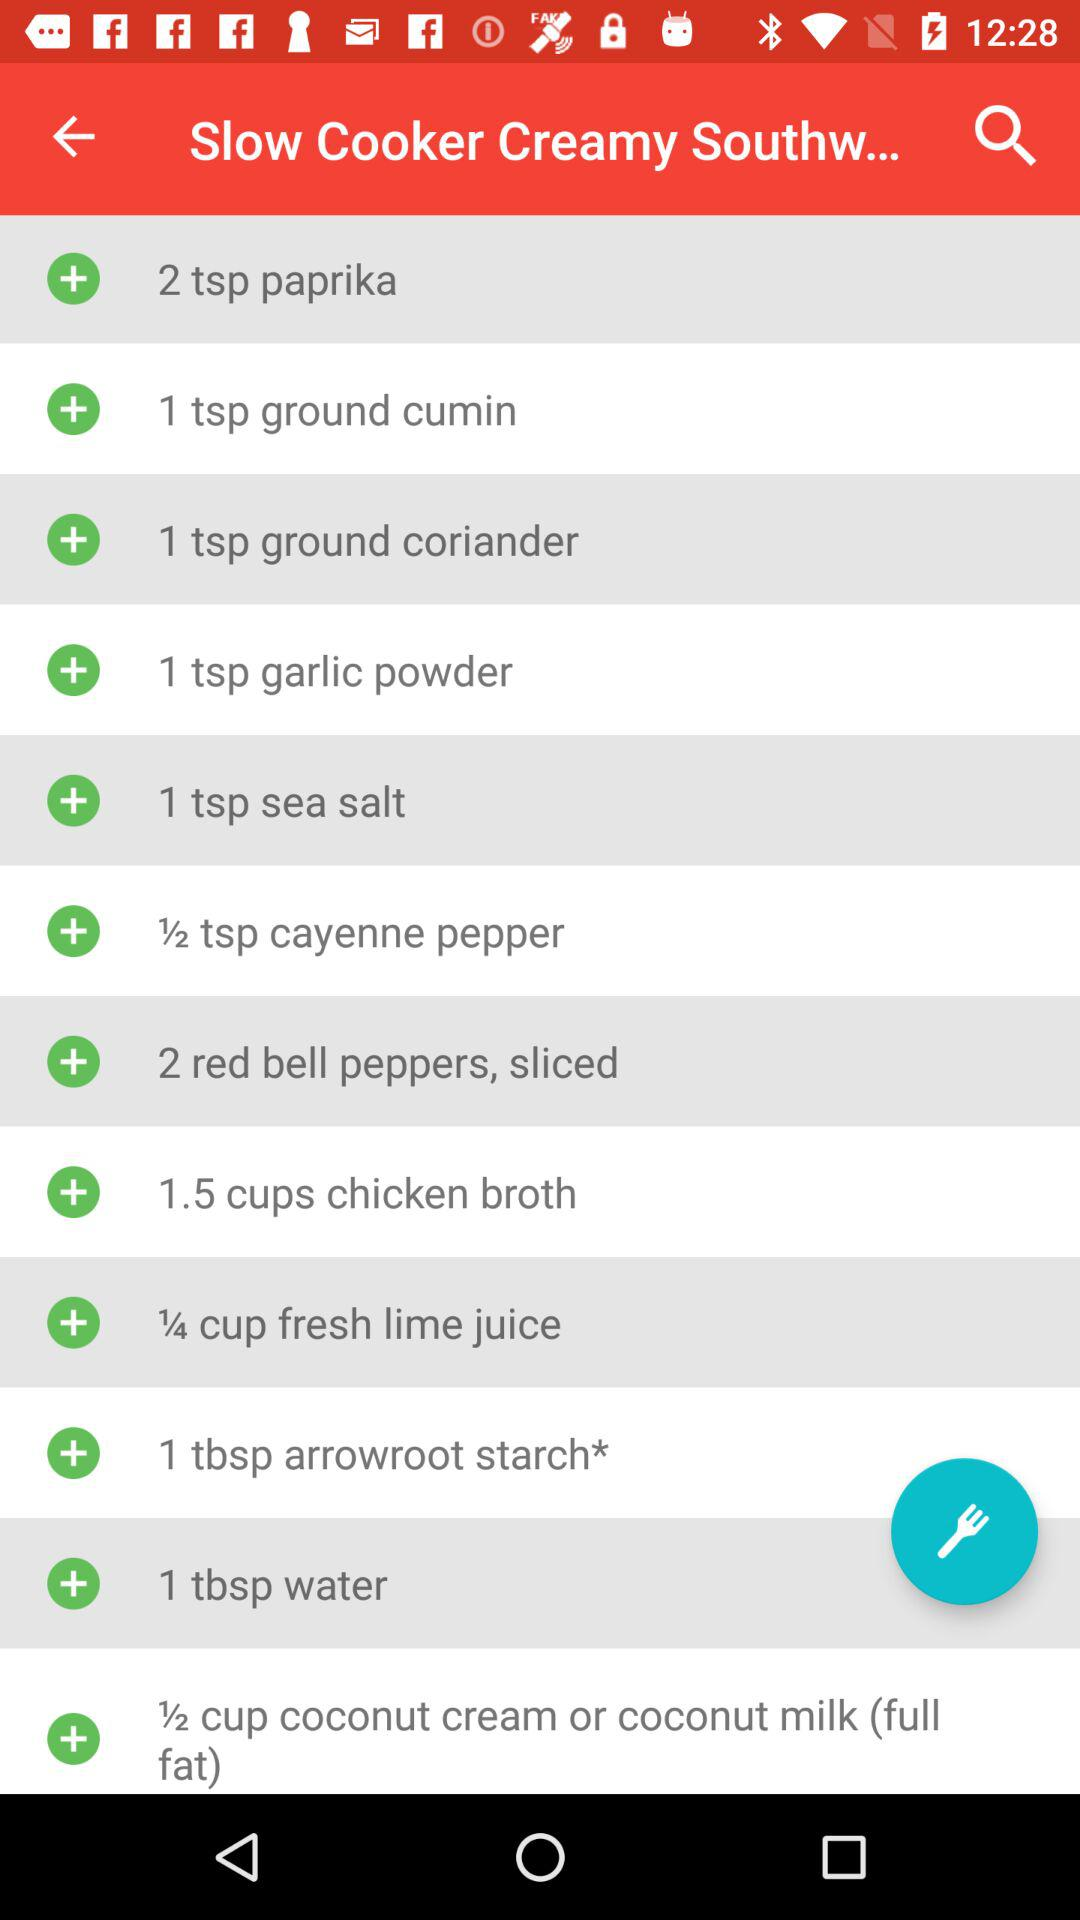How many teaspoons of garlic powder are required? The number of teaspoons of garlic powder required is 1. 